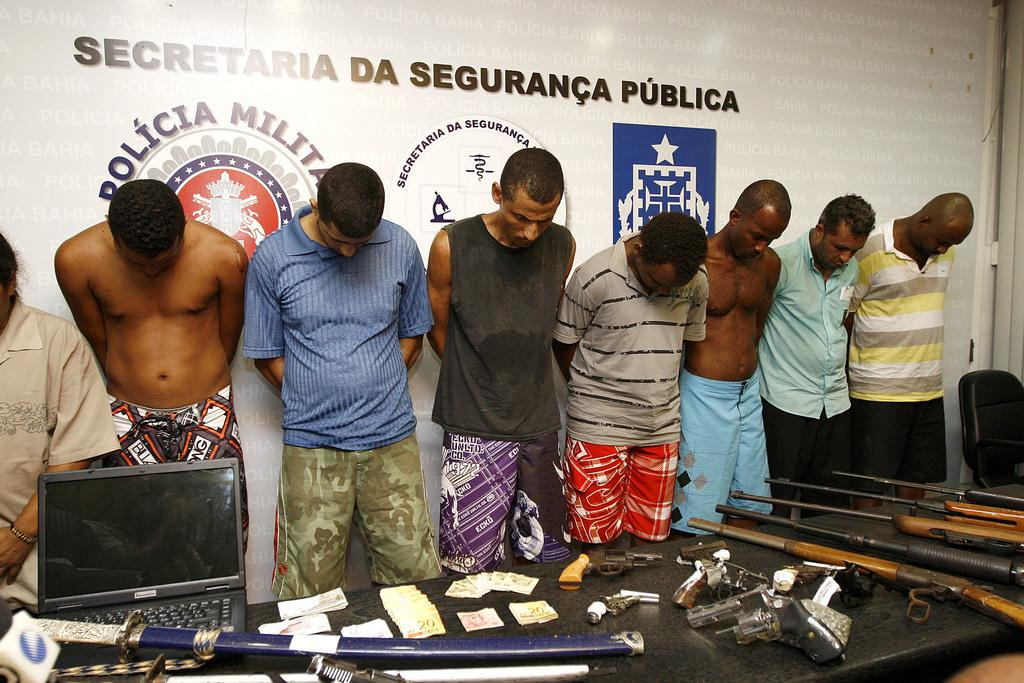How many people are standing at the table in the image? There are multiple persons standing at a table in the image. What electronic device is on the table? There is a laptop on the table. What type of items can be seen on the table besides the laptop? There are currency notes and weapons on the table. What can be seen in the background of the image? There is an advertisement visible in the background. What type of flower is the son holding in the image? There is no son or flower present in the image. How does the comfort level of the persons at the table affect the image? The comfort level of the persons at the table is not mentioned in the image, so it cannot be determined how it affects the image. 